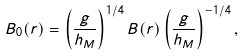<formula> <loc_0><loc_0><loc_500><loc_500>B _ { 0 } ( r ) = \left ( \frac { g } { h _ { M } } \right ) ^ { 1 / 4 } B ( r ) \left ( \frac { g } { h _ { M } } \right ) ^ { - 1 / 4 } ,</formula> 